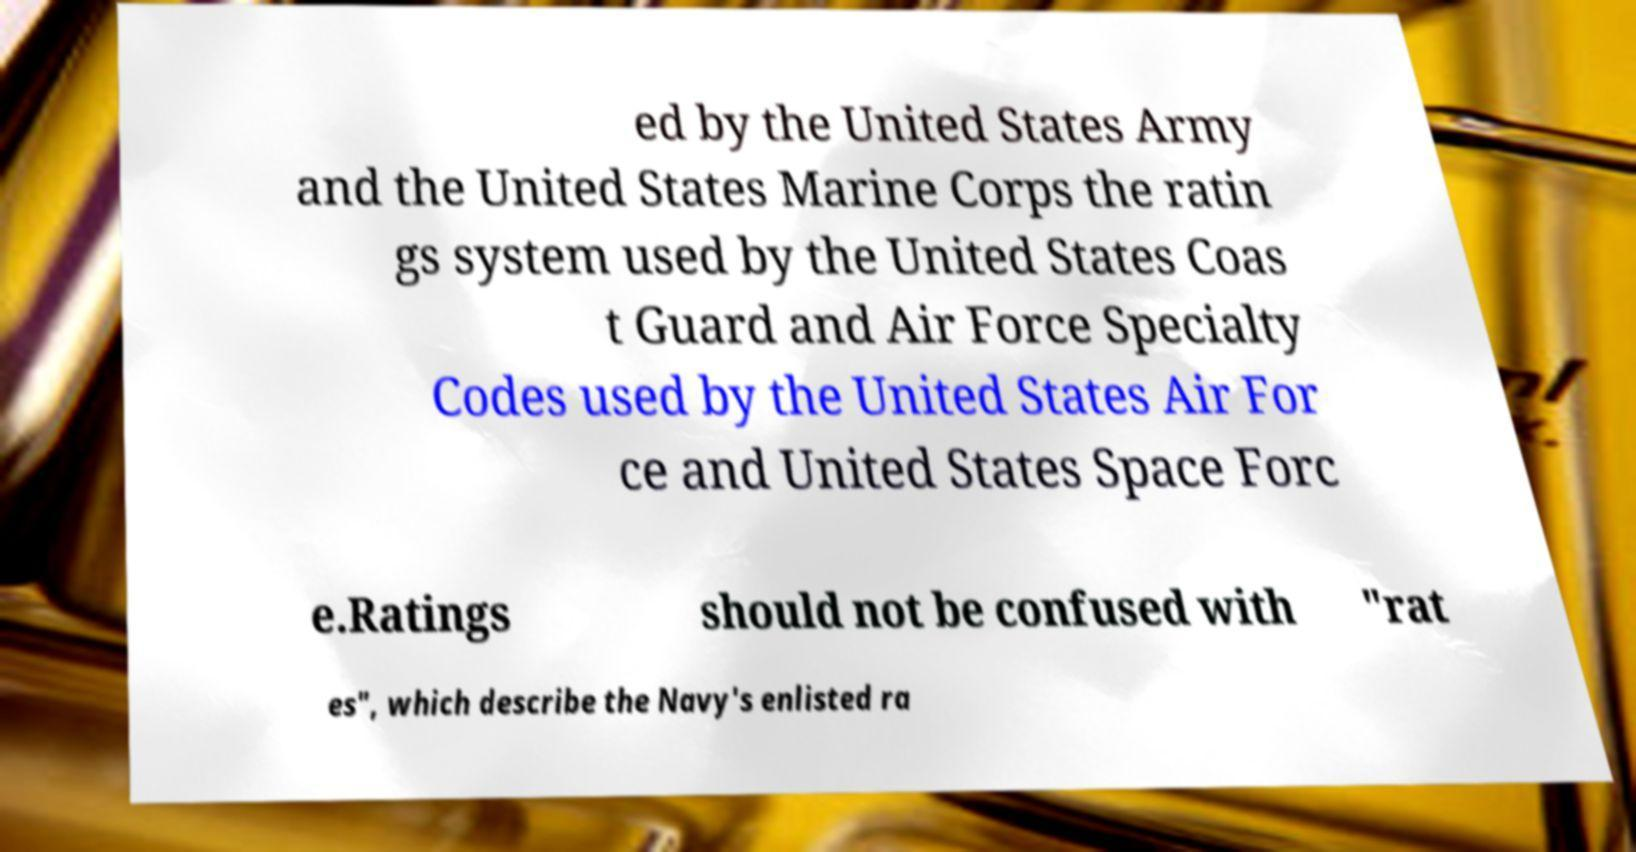For documentation purposes, I need the text within this image transcribed. Could you provide that? ed by the United States Army and the United States Marine Corps the ratin gs system used by the United States Coas t Guard and Air Force Specialty Codes used by the United States Air For ce and United States Space Forc e.Ratings should not be confused with "rat es", which describe the Navy's enlisted ra 